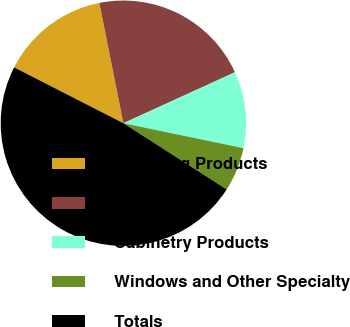<chart> <loc_0><loc_0><loc_500><loc_500><pie_chart><fcel>Plumbing Products<fcel>Unnamed: 1<fcel>Cabinetry Products<fcel>Windows and Other Specialty<fcel>Totals<nl><fcel>14.34%<fcel>21.32%<fcel>10.08%<fcel>5.81%<fcel>48.45%<nl></chart> 